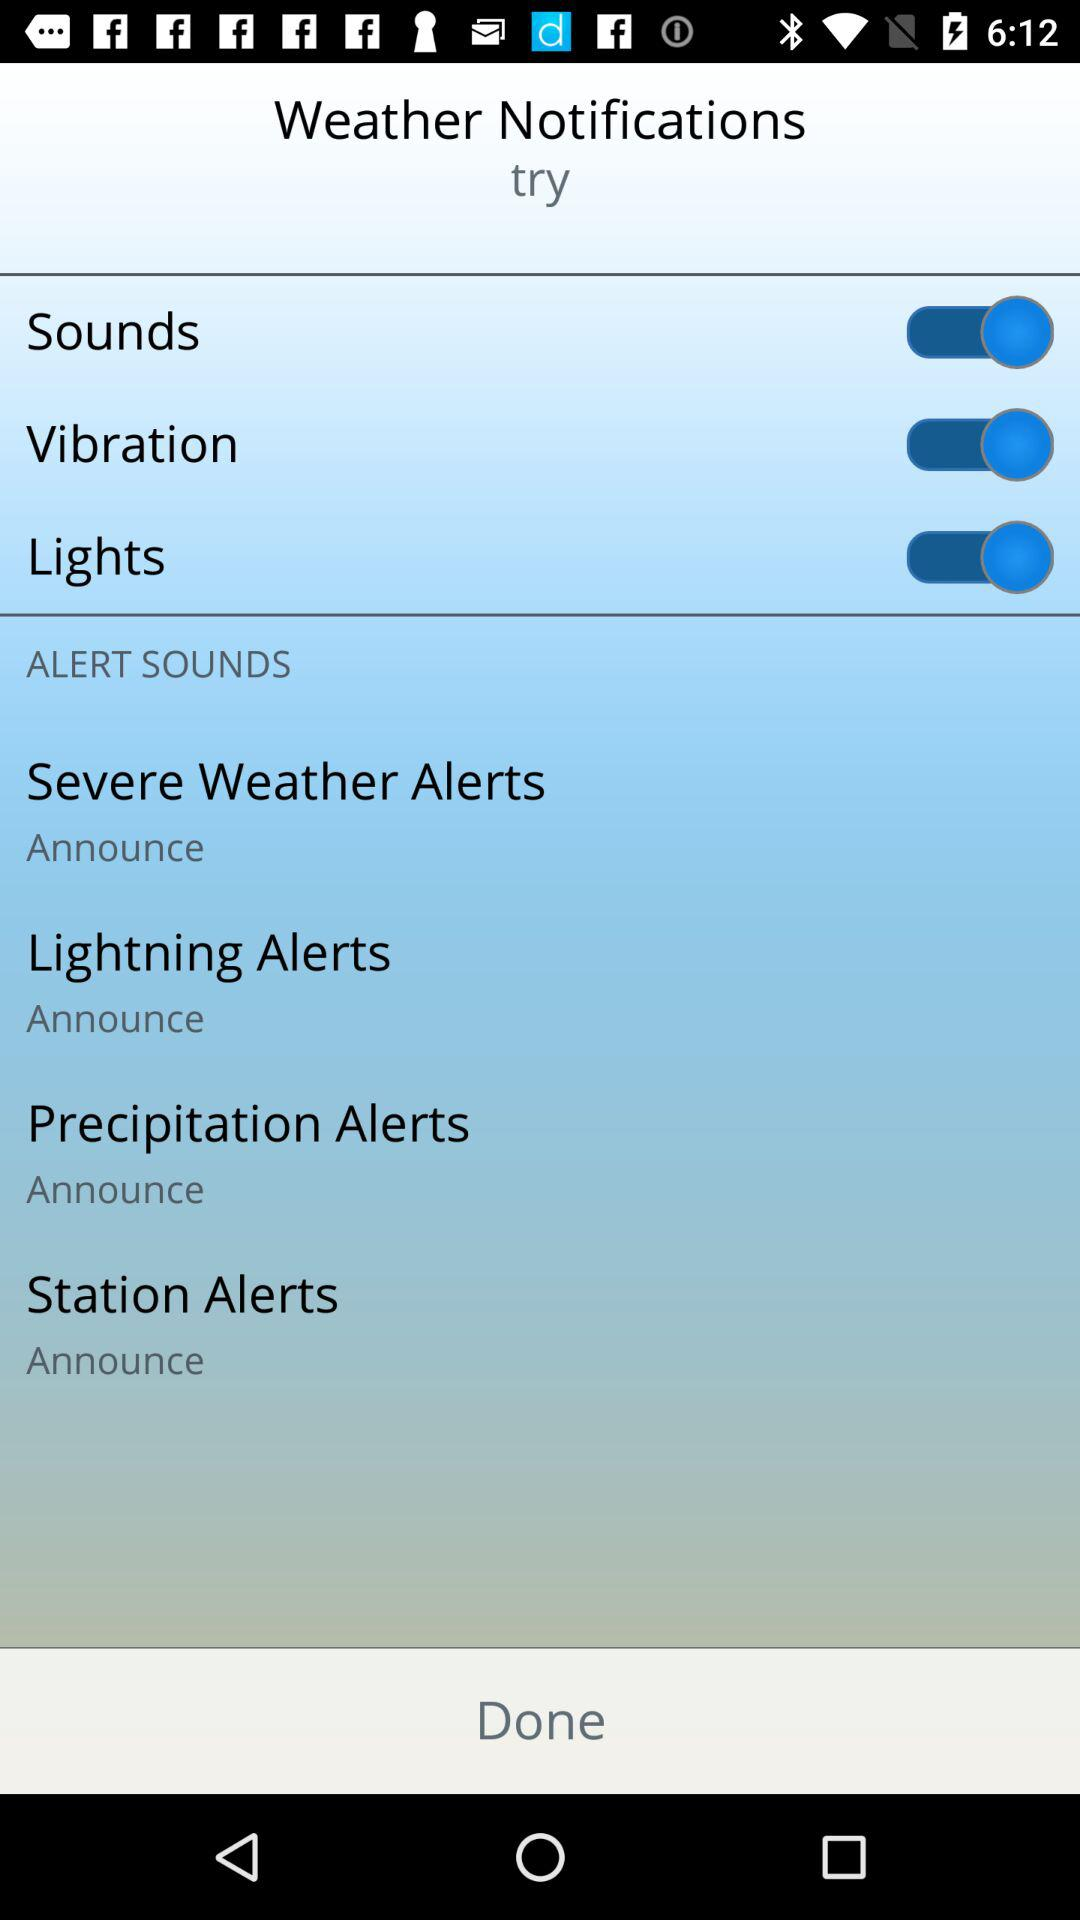Which location is selected for the weather notifications?
When the provided information is insufficient, respond with <no answer>. <no answer> 